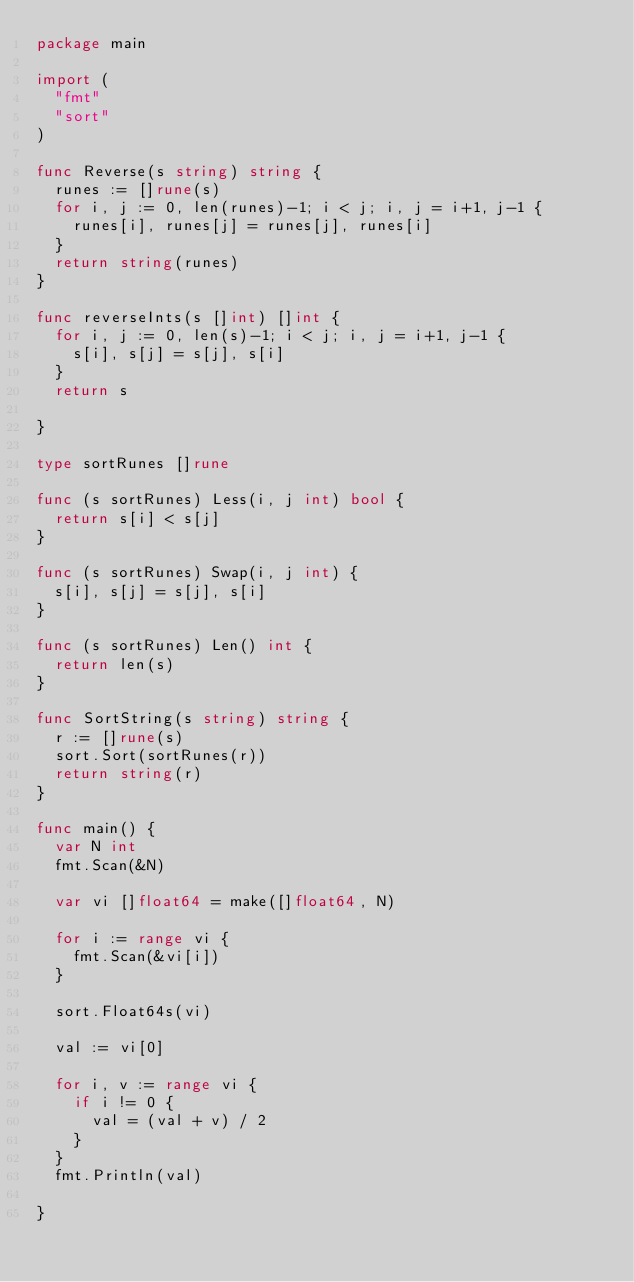<code> <loc_0><loc_0><loc_500><loc_500><_Go_>package main

import (
	"fmt"
	"sort"
)

func Reverse(s string) string {
	runes := []rune(s)
	for i, j := 0, len(runes)-1; i < j; i, j = i+1, j-1 {
		runes[i], runes[j] = runes[j], runes[i]
	}
	return string(runes)
}

func reverseInts(s []int) []int {
	for i, j := 0, len(s)-1; i < j; i, j = i+1, j-1 {
		s[i], s[j] = s[j], s[i]
	}
	return s

}

type sortRunes []rune

func (s sortRunes) Less(i, j int) bool {
	return s[i] < s[j]
}

func (s sortRunes) Swap(i, j int) {
	s[i], s[j] = s[j], s[i]
}

func (s sortRunes) Len() int {
	return len(s)
}

func SortString(s string) string {
	r := []rune(s)
	sort.Sort(sortRunes(r))
	return string(r)
}

func main() {
	var N int
	fmt.Scan(&N)

	var vi []float64 = make([]float64, N)

	for i := range vi {
		fmt.Scan(&vi[i])
	}

	sort.Float64s(vi)

	val := vi[0]

	for i, v := range vi {
		if i != 0 {
			val = (val + v) / 2
		}
	}
	fmt.Println(val)

}
</code> 